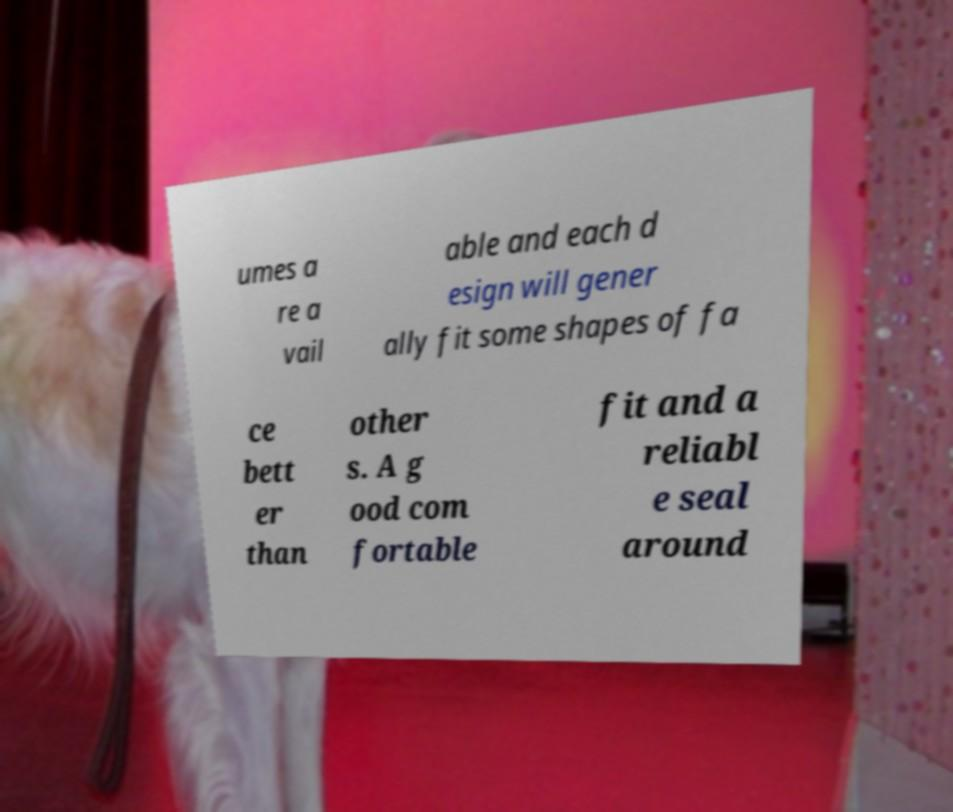I need the written content from this picture converted into text. Can you do that? umes a re a vail able and each d esign will gener ally fit some shapes of fa ce bett er than other s. A g ood com fortable fit and a reliabl e seal around 